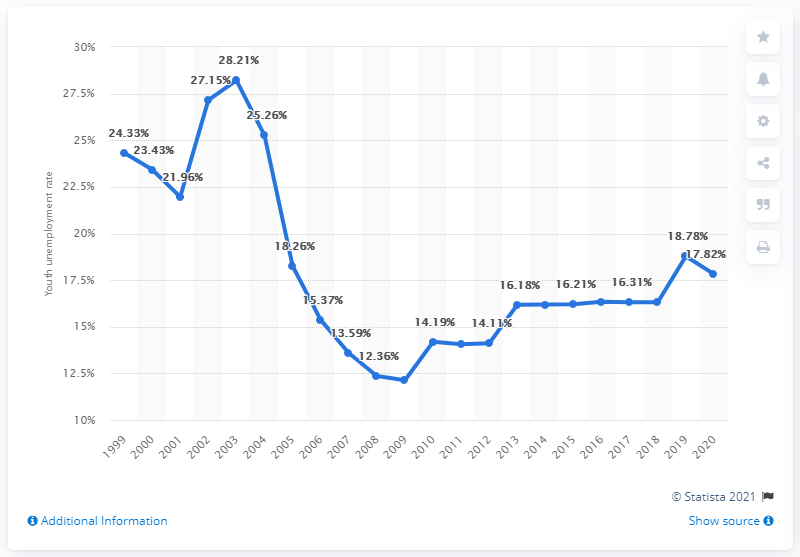Indicate a few pertinent items in this graphic. Venezuelan youth unemployment rate in 2020 was 17.82%. 